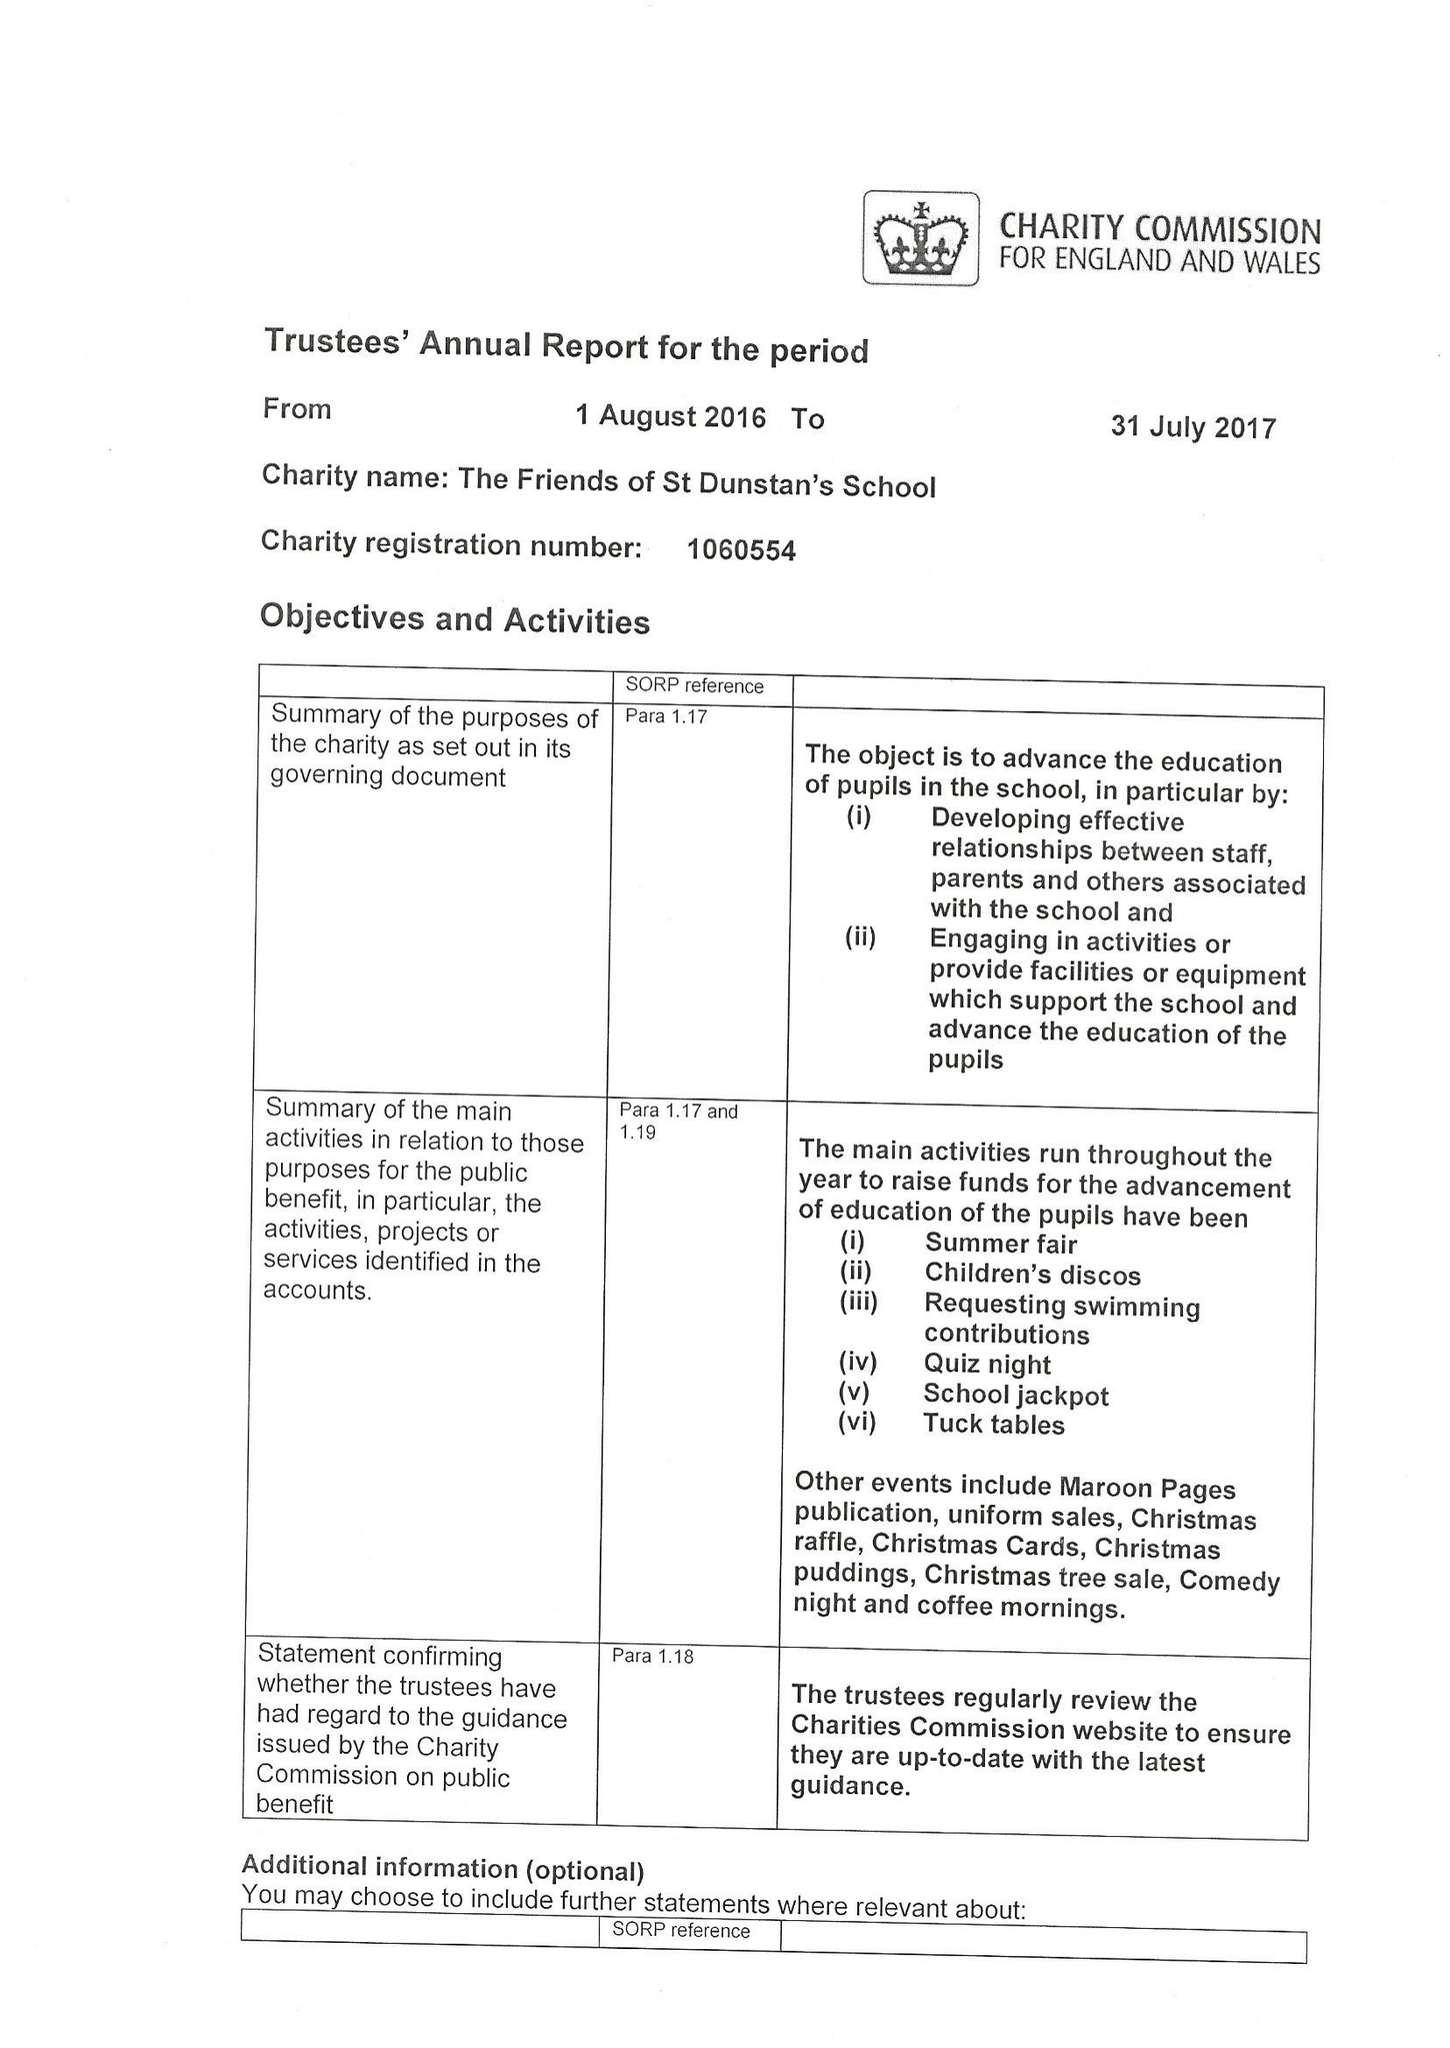What is the value for the charity_number?
Answer the question using a single word or phrase. 1060554 